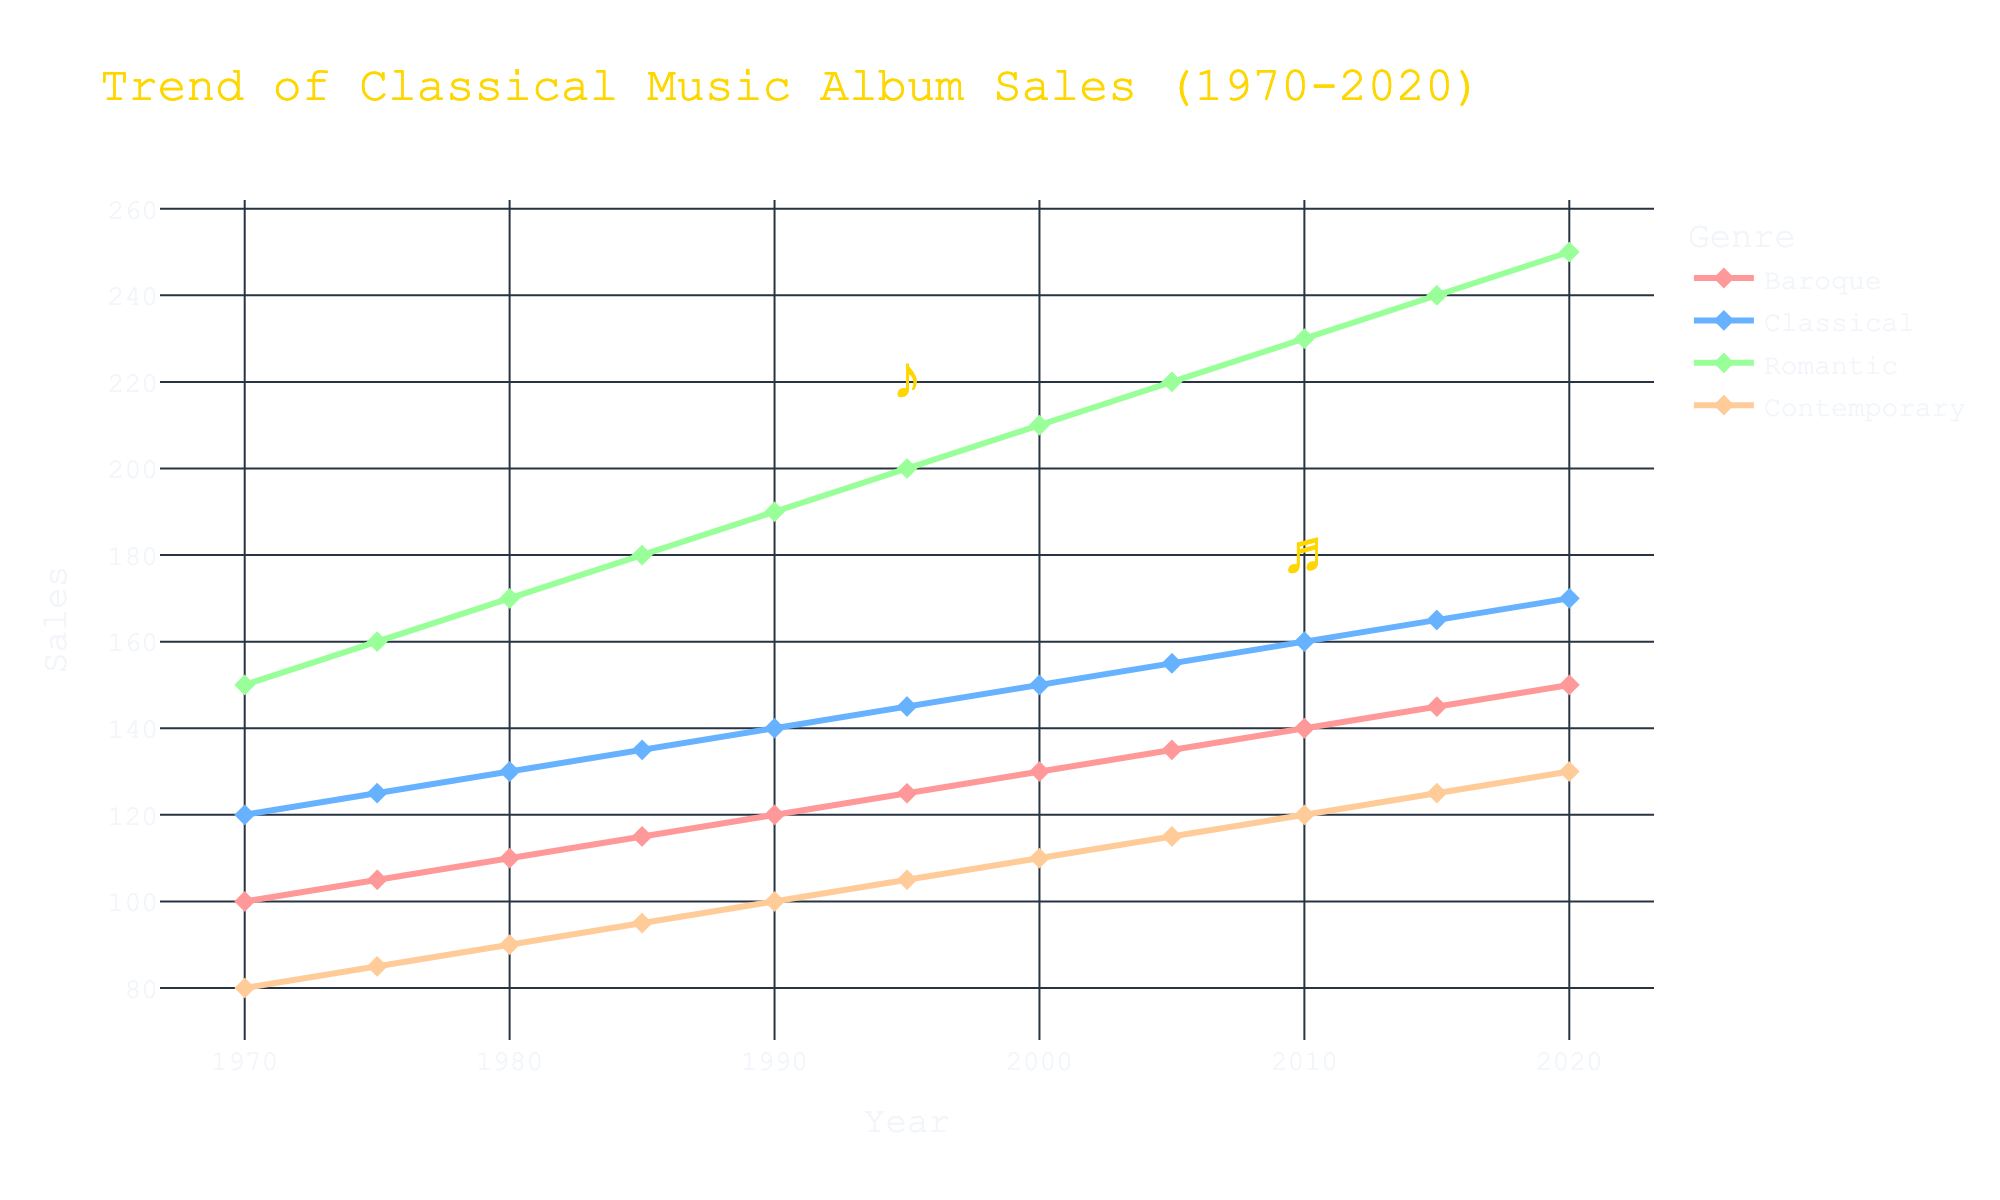What genre had the highest album sales in 1985? To determine the highest album sales in 1985, we will look at the data points for each genre in that year. The values are: Baroque (115), Classical (135), Romantic (180), Contemporary (95). The highest value is for Romantic at 180.
Answer: Romantic Between 1990 and 2000, which genre showed the greatest increase in sales? To find the genre with the greatest increase in sales between 1990 and 2000, we calculate the difference for each genre: Baroque (130 - 120 = 10), Classical (150 - 140 = 10), Romantic (210 - 190 = 20), Contemporary (110 - 100 = 10). The greatest increase is observed in Romantic (20).
Answer: Romantic Considering the year 2010, how many more albums were sold in the Romantic genre compared to the Baroque genre? To determine the difference in sales between Romantic and Baroque genres in 2010, subtract the Baroque sales from the Romantic sales: 230 (Romantic) - 140 (Baroque) = 90.
Answer: 90 What is the average increase in sales per decade for the Contemporary genre from 1970 to 2020? Calculate the increase in sales for each decade and find the average: 
1970-1980 (90 - 80 = 10)
1980-1990 (100 - 90 = 10)
1990-2000 (110 - 100 = 10)
2000-2010 (120 - 110 = 10)
2010-2020 (130 - 120 = 10)
Sum these increases (10 + 10 + 10 + 10 + 10 = 50) and divide by 5 decades: 50/5 = 10.
Answer: 10 In which year did the sales for the Baroque genre reach 145? Identify the year with Baroque sales of 145 from the data. This occurred in the year 2015.
Answer: 2015 Which genre exhibited the most consistent growth in album sales over the 50-year period? Observing the trends, all genres show consistent growth as depicted by the steadily increasing lines over the years. However, a close review shows Baroque, Classical, and Contemporary have slight increases and Romantic shows the largest and consistent increase with no variation in the rate of growth.
Answer: Romantic How do the sales of the Classical genre in 2005 compare to those of the Baroque genre in 2015? To compare these values, note the sales for Classical in 2005 (155) and Baroque in 2015 (145). Classical sales are higher by 10 albums.
Answer: Classical is 10 higher By how much did the sales for the Contemporary genre increase from 1995 to 2015? Compute the difference in sales of Contemporary albums between 1995 and 2015: 125 (2015) - 105 (1995) = 20.
Answer: 20 How many albums in total were sold across all genres in the year 2000? Sum the sales for all genres in 2000: 130 (Baroque) + 150 (Classical) + 210 (Romantic) + 110 (Contemporary) = 600.
Answer: 600 Which genre has the second-highest sales in 2020 and how many albums were sold in that genre? To identify the second-highest sales in 2020, review the sales numbers: Baroque (150), Classical (170), Romantic (250), Contemporary (130). The second-highest number is for Classical with 170.
Answer: Classical with 170 